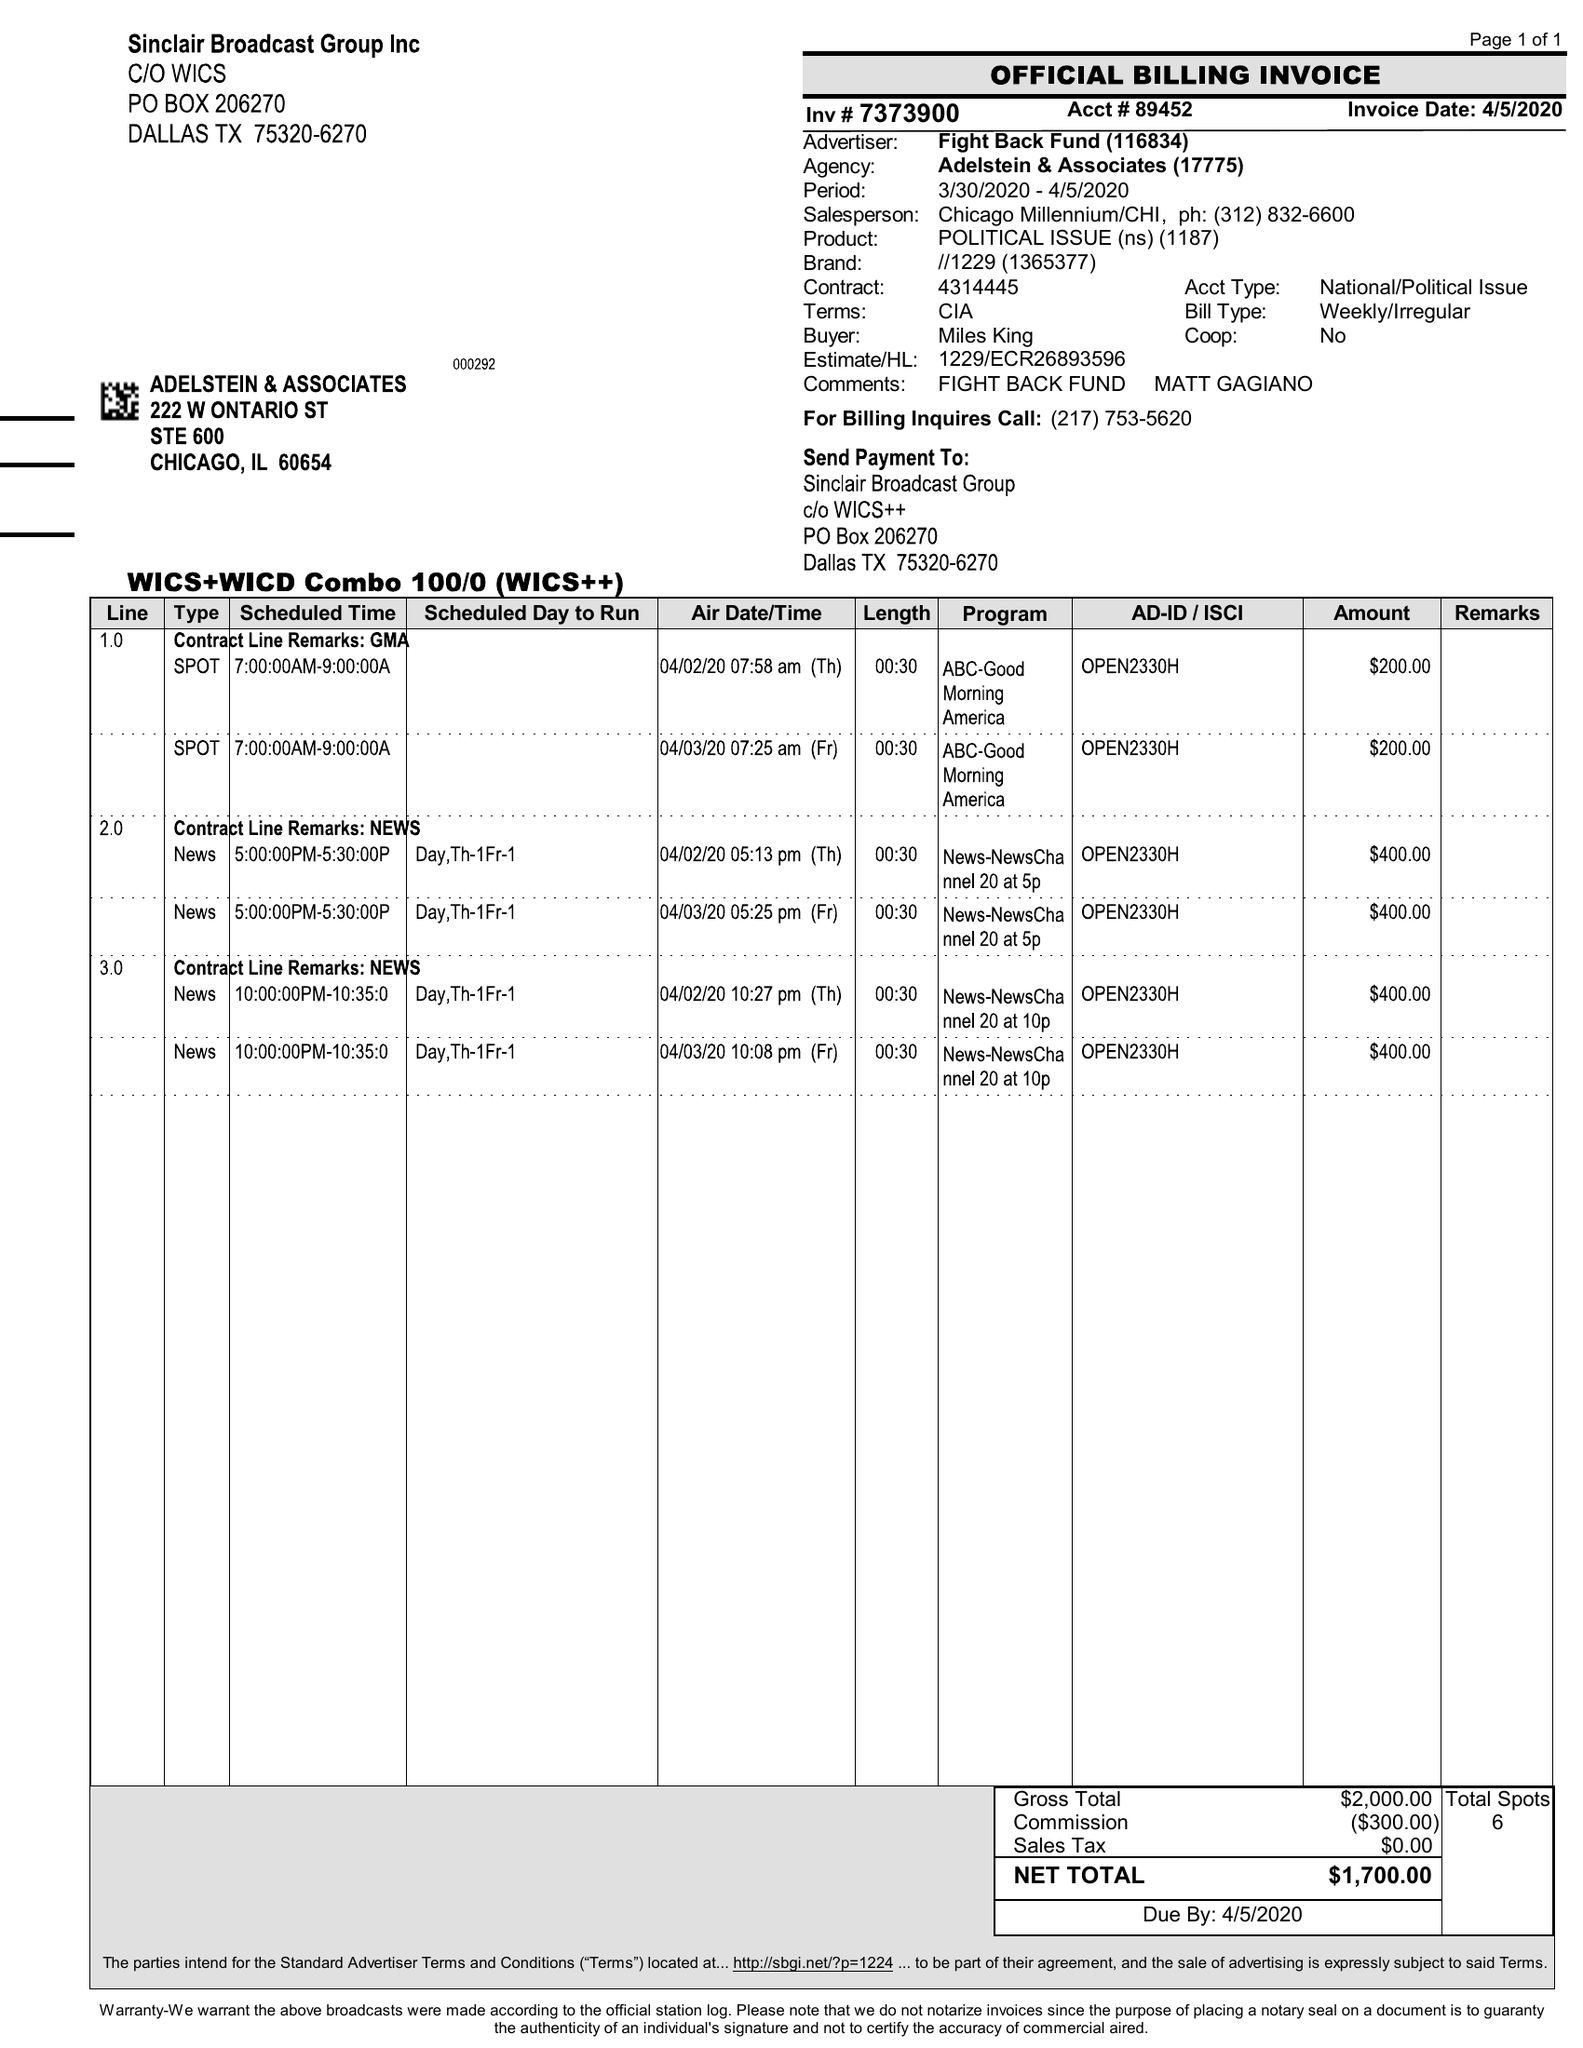What is the value for the contract_num?
Answer the question using a single word or phrase. 4314445 